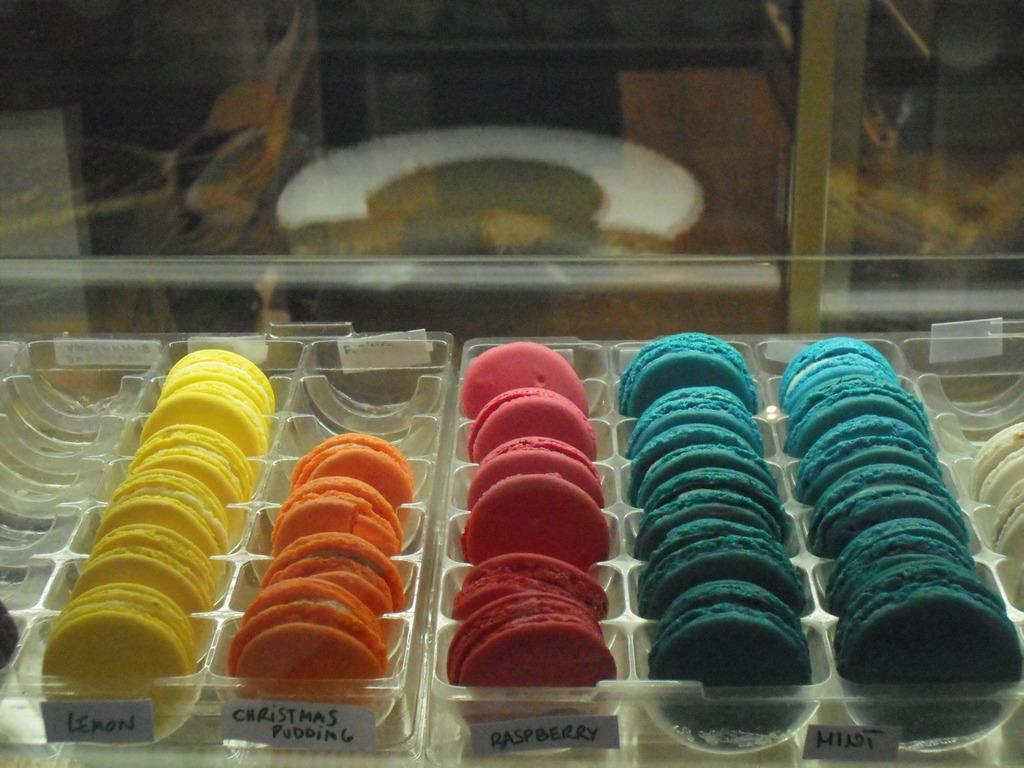<image>
Describe the image concisely. Lemon, raspberry, mint, and Christmas pudding whoopie pies are in separate trays behind a glass counter. 